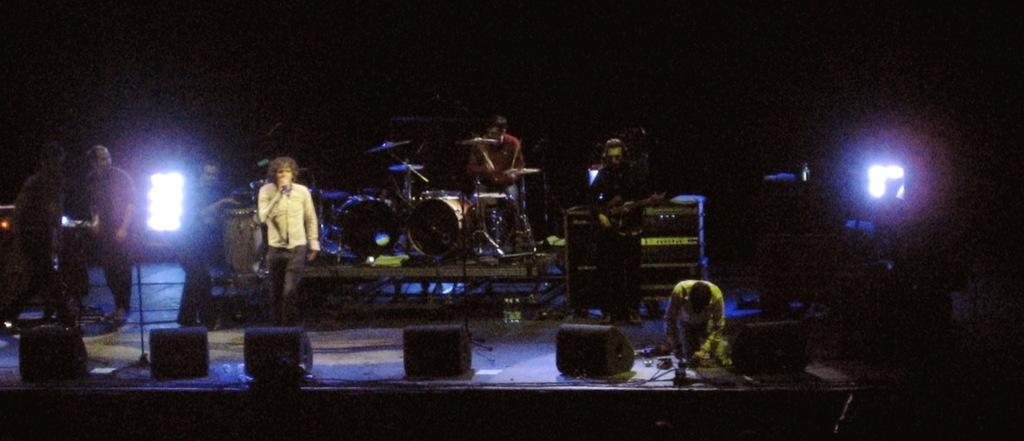In one or two sentences, can you explain what this image depicts? There is a stage in this picture on which a music band is there. Four of them were playing music. Everyone is having a different musical instrument in front of them. One guy singing with mic in her hand. In the background there are some lights here. 